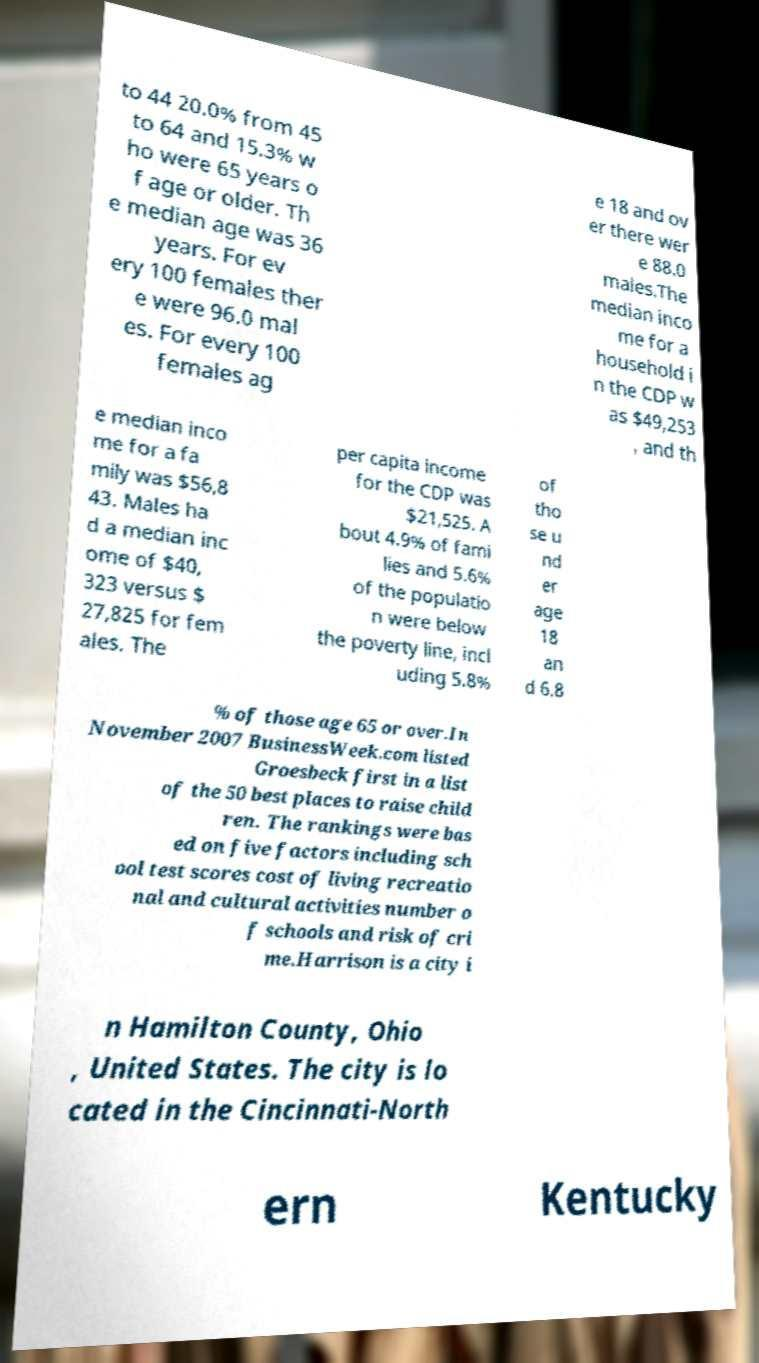There's text embedded in this image that I need extracted. Can you transcribe it verbatim? to 44 20.0% from 45 to 64 and 15.3% w ho were 65 years o f age or older. Th e median age was 36 years. For ev ery 100 females ther e were 96.0 mal es. For every 100 females ag e 18 and ov er there wer e 88.0 males.The median inco me for a household i n the CDP w as $49,253 , and th e median inco me for a fa mily was $56,8 43. Males ha d a median inc ome of $40, 323 versus $ 27,825 for fem ales. The per capita income for the CDP was $21,525. A bout 4.9% of fami lies and 5.6% of the populatio n were below the poverty line, incl uding 5.8% of tho se u nd er age 18 an d 6.8 % of those age 65 or over.In November 2007 BusinessWeek.com listed Groesbeck first in a list of the 50 best places to raise child ren. The rankings were bas ed on five factors including sch ool test scores cost of living recreatio nal and cultural activities number o f schools and risk of cri me.Harrison is a city i n Hamilton County, Ohio , United States. The city is lo cated in the Cincinnati-North ern Kentucky 